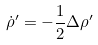<formula> <loc_0><loc_0><loc_500><loc_500>\dot { \rho } ^ { \prime } = - \frac { 1 } { 2 } \Delta \rho ^ { \prime }</formula> 